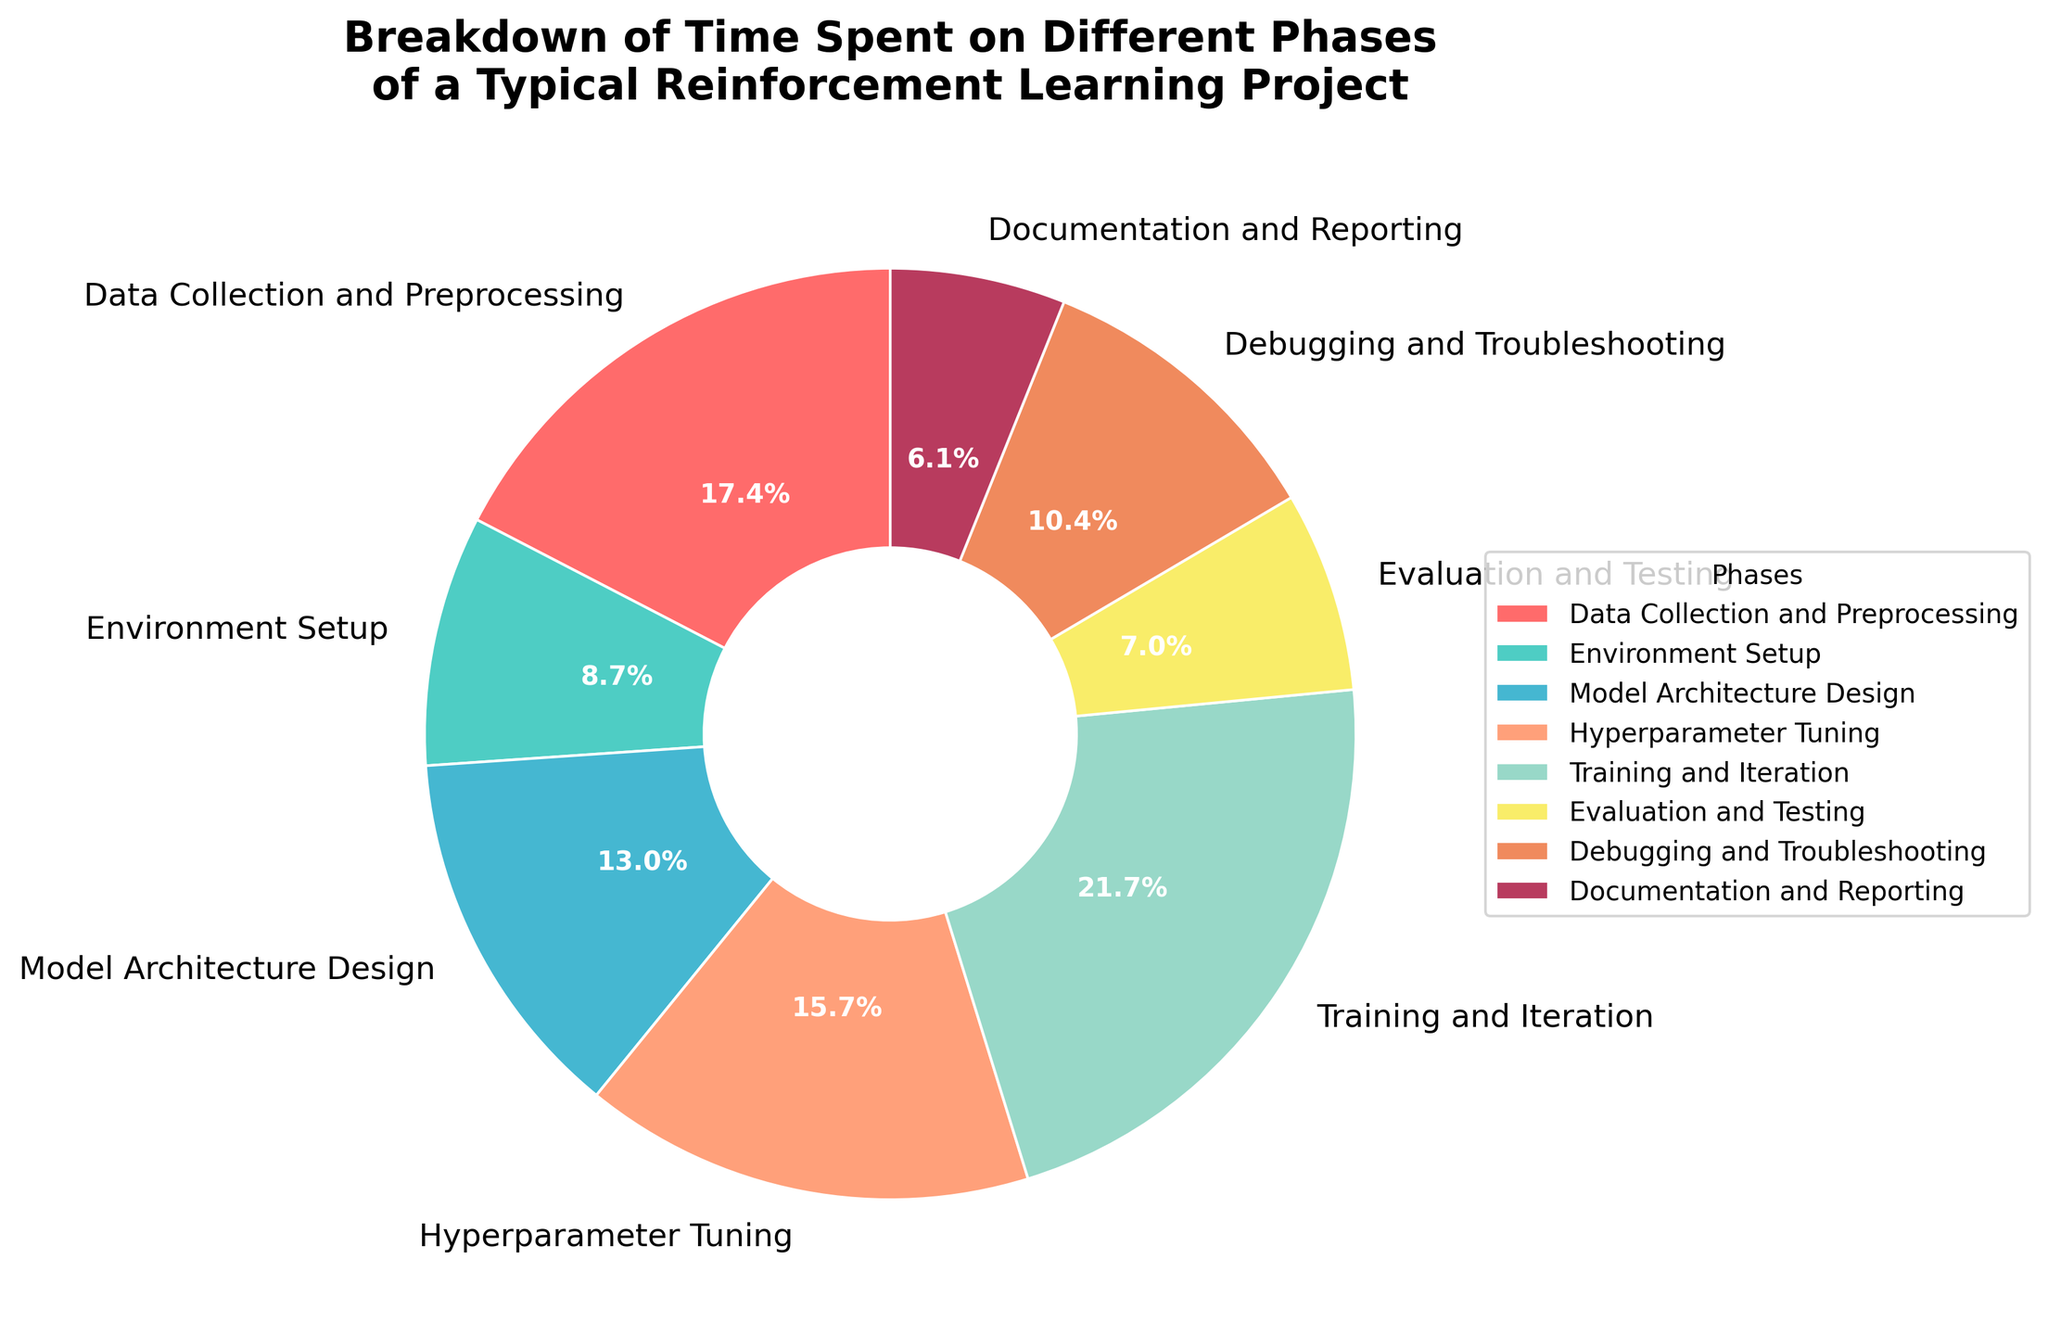Which phase takes up the largest percentage of time in a typical reinforcement learning project? The phase that takes up the largest percentage of time can be identified by looking at the phase with the largest slice in the pie chart. Training and Iteration has the largest slice representing 25%.
Answer: Training and Iteration How much total time is spent on Environment Setup and Hyperparameter Tuning combined? To find the total time spent on Environment Setup and Hyperparameter Tuning combined, add their respective percentages: 10% (Environment Setup) + 18% (Hyperparameter Tuning) = 28%.
Answer: 28% Which phases take up less than 10% of time each? The phases that take up less than 10% of time can be identified by looking at the slices representing less than 10%. Both Evaluation and Testing (8%) and Documentation and Reporting (7%) fit this criterion.
Answer: Evaluation and Testing, Documentation and Reporting What is the difference in time spent between Data Collection and Preprocessing and Evaluation and Testing? To find the difference, subtract the percentage of Evaluation and Testing from Data Collection and Preprocessing: 20% (Data Collection and Preprocessing) - 8% (Evaluation and Testing) = 12%.
Answer: 12% Is more time spent on Model Architecture Design or on Debugging and Troubleshooting? By comparing the slices, Model Architecture Design is 15% and Debugging and Troubleshooting is 12%. Therefore, more time is spent on Model Architecture Design.
Answer: Model Architecture Design What is the combined percentage of time spent on phases related to setup and debugging (i.e., Environment Setup and Debugging and Troubleshooting)? Add the percentages for Environment Setup and Debugging and Troubleshooting: 10% (Environment Setup) + 12% (Debugging and Troubleshooting) = 22%.
Answer: 22% How does the percentage of time spent on Training and Iteration compare to the time spent on Hyperparameter Tuning? Compare the slices for Training and Iteration (25%) and Hyperparameter Tuning (18%), noting that Training and Iteration takes up a higher percentage.
Answer: Training and Iteration takes up more time Which color represents the Documentation and Reporting phase in the pie chart? According to the custom color palette provided, the Documentation and Reporting phase is represented by the color which appears near the smallest slices. The color used for Documentation and Reporting is likely '#FFA07A' (Light Salmon).
Answer: Light Salmon (or #FFA07A) Does Data Collection and Preprocessing take up a larger percentage of time than both Model Architecture Design and Evaluation and Testing combined? Adding the percentages for Model Architecture Design (15%) and Evaluation and Testing (8%) = 23%. Comparing this with the percentage for Data Collection and Preprocessing (20%), it takes up a smaller percentage.
Answer: No 